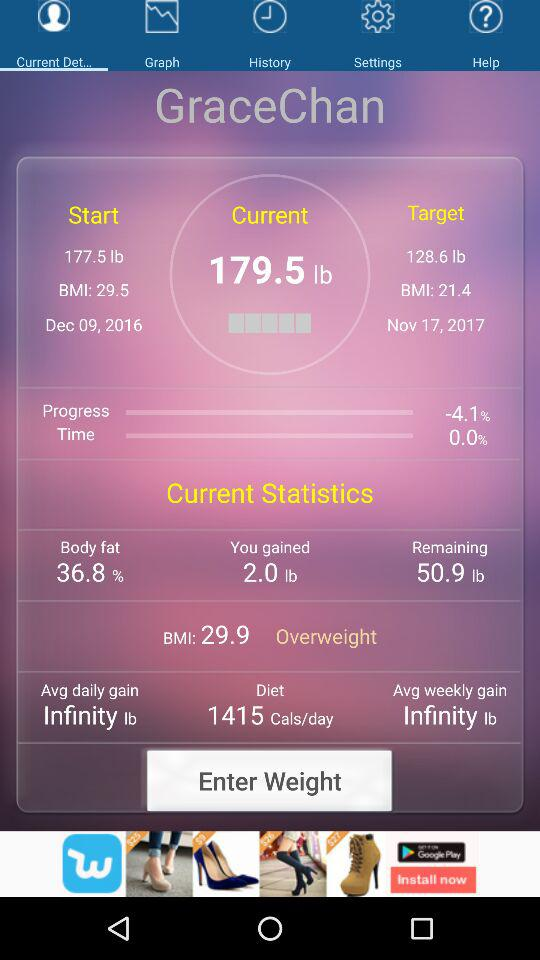How much weight was gained in the last 10 months?
Answer the question using a single word or phrase. 2.0 lb 